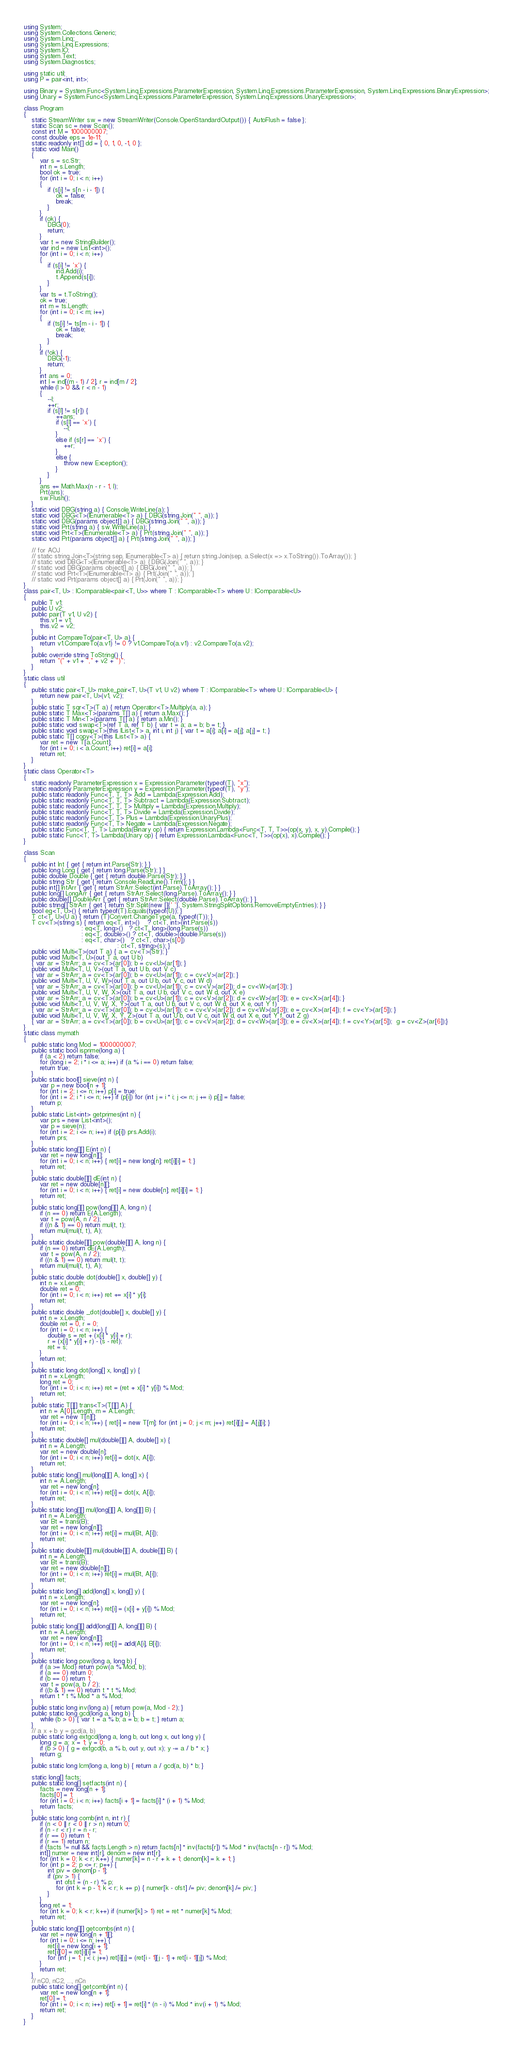<code> <loc_0><loc_0><loc_500><loc_500><_C#_>using System;
using System.Collections.Generic;
using System.Linq;
using System.Linq.Expressions;
using System.IO;
using System.Text;
using System.Diagnostics;

using static util;
using P = pair<int, int>;

using Binary = System.Func<System.Linq.Expressions.ParameterExpression, System.Linq.Expressions.ParameterExpression, System.Linq.Expressions.BinaryExpression>;
using Unary = System.Func<System.Linq.Expressions.ParameterExpression, System.Linq.Expressions.UnaryExpression>;

class Program
{
    static StreamWriter sw = new StreamWriter(Console.OpenStandardOutput()) { AutoFlush = false };
    static Scan sc = new Scan();
    const int M = 1000000007;
    const double eps = 1e-11;
    static readonly int[] dd = { 0, 1, 0, -1, 0 };
    static void Main()
    {
        var s = sc.Str;
        int n = s.Length;
        bool ok = true;
        for (int i = 0; i < n; i++)
        {
            if (s[i] != s[n - i - 1]) {
                ok = false;
                break;
            }
        }
        if (ok) {
            DBG(0);
            return;
        }
        var t = new StringBuilder();
        var ind = new List<int>();
        for (int i = 0; i < n; i++)
        {
            if (s[i] != 'x') {
                ind.Add(i);
                t.Append(s[i]);
            }
        }
        var ts = t.ToString();
        ok = true;
        int m = ts.Length;
        for (int i = 0; i < m; i++)
        {
            if (ts[i] != ts[m - i - 1]) {
                ok = false;
                break;
            }
        }
        if (!ok) {
            DBG(-1);
            return;
        }
        int ans = 0;
        int l = ind[(m - 1) / 2], r = ind[m / 2];
        while (l > 0 && r < n - 1)
        {
            --l;
            ++r;
            if (s[l] != s[r]) {
                ++ans;
                if (s[l] == 'x') {
                    --l;
                }
                else if (s[r] == 'x') {
                    ++r;
                }
                else {
                    throw new Exception();
                }
            }
        }
        ans += Math.Max(n - r - 1, l);
        Prt(ans);
        sw.Flush();
    }
    static void DBG(string a) { Console.WriteLine(a); }
    static void DBG<T>(IEnumerable<T> a) { DBG(string.Join(" ", a)); }
    static void DBG(params object[] a) { DBG(string.Join(" ", a)); }
    static void Prt(string a) { sw.WriteLine(a); }
    static void Prt<T>(IEnumerable<T> a) { Prt(string.Join(" ", a)); }
    static void Prt(params object[] a) { Prt(string.Join(" ", a)); }

    // for AOJ
    // static string Join<T>(string sep, IEnumerable<T> a) { return string.Join(sep, a.Select(x => x.ToString()).ToArray()); }
    // static void DBG<T>(IEnumerable<T> a) { DBG(Join(" ", a)); }
    // static void DBG(params object[] a) { DBG(Join(" ", a)); }
    // static void Prt<T>(IEnumerable<T> a) { Prt(Join(" ", a)); }
    // static void Prt(params object[] a) { Prt(Join(" ", a)); }
}
class pair<T, U> : IComparable<pair<T, U>> where T : IComparable<T> where U : IComparable<U>
{
    public T v1;
    public U v2;
    public pair(T v1, U v2) {
        this.v1 = v1;
        this.v2 = v2;
    }
    public int CompareTo(pair<T, U> a) {
        return v1.CompareTo(a.v1) != 0 ? v1.CompareTo(a.v1) : v2.CompareTo(a.v2);
    }
    public override string ToString() {
        return "(" + v1 + "," + v2 + ")";
    }
}
static class util
{
    public static pair<T, U> make_pair<T, U>(T v1, U v2) where T : IComparable<T> where U : IComparable<U> {
        return new pair<T, U>(v1, v2);
    }
    public static T sqr<T>(T a) { return Operator<T>.Multiply(a, a); }
    public static T Max<T>(params T[] a) { return a.Max(); }
    public static T Min<T>(params T[] a) { return a.Min(); }
    public static void swap<T>(ref T a, ref T b) { var t = a; a = b; b = t; }
    public static void swap<T>(this IList<T> a, int i, int j) { var t = a[i]; a[i] = a[j]; a[j] = t; }
    public static T[] copy<T>(this IList<T> a) {
        var ret = new T[a.Count];
        for (int i = 0; i < a.Count; i++) ret[i] = a[i];
        return ret;
    }
}
static class Operator<T>
{
    static readonly ParameterExpression x = Expression.Parameter(typeof(T), "x");
    static readonly ParameterExpression y = Expression.Parameter(typeof(T), "y");
    public static readonly Func<T, T, T> Add = Lambda(Expression.Add);
    public static readonly Func<T, T, T> Subtract = Lambda(Expression.Subtract);
    public static readonly Func<T, T, T> Multiply = Lambda(Expression.Multiply);
    public static readonly Func<T, T, T> Divide = Lambda(Expression.Divide);
    public static readonly Func<T, T> Plus = Lambda(Expression.UnaryPlus);
    public static readonly Func<T, T> Negate = Lambda(Expression.Negate);
    public static Func<T, T, T> Lambda(Binary op) { return Expression.Lambda<Func<T, T, T>>(op(x, y), x, y).Compile(); }
    public static Func<T, T> Lambda(Unary op) { return Expression.Lambda<Func<T, T>>(op(x), x).Compile(); }
}

class Scan
{
    public int Int { get { return int.Parse(Str); } }
    public long Long { get { return long.Parse(Str); } }
    public double Double { get { return double.Parse(Str); } }
    public string Str { get { return Console.ReadLine().Trim(); } }
    public int[] IntArr { get { return StrArr.Select(int.Parse).ToArray(); } }
    public long[] LongArr { get { return StrArr.Select(long.Parse).ToArray(); } }
    public double[] DoubleArr { get { return StrArr.Select(double.Parse).ToArray(); } }
    public string[] StrArr { get { return Str.Split(new []{' '}, System.StringSplitOptions.RemoveEmptyEntries); } }
    bool eq<T, U>() { return typeof(T).Equals(typeof(U)); }
    T ct<T, U>(U a) { return (T)Convert.ChangeType(a, typeof(T)); }
    T cv<T>(string s) { return eq<T, int>()    ? ct<T, int>(int.Parse(s))
                             : eq<T, long>()   ? ct<T, long>(long.Parse(s))
                             : eq<T, double>() ? ct<T, double>(double.Parse(s))
                             : eq<T, char>()   ? ct<T, char>(s[0])
                                               : ct<T, string>(s); }
    public void Multi<T>(out T a) { a = cv<T>(Str); }
    public void Multi<T, U>(out T a, out U b)
    { var ar = StrArr; a = cv<T>(ar[0]); b = cv<U>(ar[1]); }
    public void Multi<T, U, V>(out T a, out U b, out V c)
    { var ar = StrArr; a = cv<T>(ar[0]); b = cv<U>(ar[1]); c = cv<V>(ar[2]); }
    public void Multi<T, U, V, W>(out T a, out U b, out V c, out W d)
    { var ar = StrArr; a = cv<T>(ar[0]); b = cv<U>(ar[1]); c = cv<V>(ar[2]); d = cv<W>(ar[3]); }
    public void Multi<T, U, V, W, X>(out T a, out U b, out V c, out W d, out X e)
    { var ar = StrArr; a = cv<T>(ar[0]); b = cv<U>(ar[1]); c = cv<V>(ar[2]); d = cv<W>(ar[3]); e = cv<X>(ar[4]); }
    public void Multi<T, U, V, W, X, Y>(out T a, out U b, out V c, out W d, out X e, out Y f)
    { var ar = StrArr; a = cv<T>(ar[0]); b = cv<U>(ar[1]); c = cv<V>(ar[2]); d = cv<W>(ar[3]); e = cv<X>(ar[4]); f = cv<Y>(ar[5]); }
    public void Multi<T, U, V, W, X, Y, Z>(out T a, out U b, out V c, out W d, out X e, out Y f, out Z g)
    { var ar = StrArr; a = cv<T>(ar[0]); b = cv<U>(ar[1]); c = cv<V>(ar[2]); d = cv<W>(ar[3]); e = cv<X>(ar[4]); f = cv<Y>(ar[5]);  g = cv<Z>(ar[6]);}
}
static class mymath
{
    public static long Mod = 1000000007;
    public static bool isprime(long a) {
        if (a < 2) return false;
        for (long i = 2; i * i <= a; i++) if (a % i == 0) return false;
        return true;
    }
    public static bool[] sieve(int n) {
        var p = new bool[n + 1];
        for (int i = 2; i <= n; i++) p[i] = true;
        for (int i = 2; i * i <= n; i++) if (p[i]) for (int j = i * i; j <= n; j += i) p[j] = false;
        return p;
    }
    public static List<int> getprimes(int n) {
        var prs = new List<int>();
        var p = sieve(n);
        for (int i = 2; i <= n; i++) if (p[i]) prs.Add(i);
        return prs;
    }
    public static long[][] E(int n) {
        var ret = new long[n][];
        for (int i = 0; i < n; i++) { ret[i] = new long[n]; ret[i][i] = 1; }
        return ret;
    }
    public static double[][] dE(int n) {
        var ret = new double[n][];
        for (int i = 0; i < n; i++) { ret[i] = new double[n]; ret[i][i] = 1; }
        return ret;
    }
    public static long[][] pow(long[][] A, long n) {
        if (n == 0) return E(A.Length);
        var t = pow(A, n / 2);
        if ((n & 1) == 0) return mul(t, t);
        return mul(mul(t, t), A);
    }
    public static double[][] pow(double[][] A, long n) {
        if (n == 0) return dE(A.Length);
        var t = pow(A, n / 2);
        if ((n & 1) == 0) return mul(t, t);
        return mul(mul(t, t), A);
    }
    public static double dot(double[] x, double[] y) {
        int n = x.Length;
        double ret = 0;
        for (int i = 0; i < n; i++) ret += x[i] * y[i];
        return ret;
    }
    public static double _dot(double[] x, double[] y) {
        int n = x.Length;
        double ret = 0, r = 0;
        for (int i = 0; i < n; i++) {
            double s = ret + (x[i] * y[i] + r);
            r = (x[i] * y[i] + r) - (s - ret);
            ret = s;
        }
        return ret;
    }
    public static long dot(long[] x, long[] y) {
        int n = x.Length;
        long ret = 0;
        for (int i = 0; i < n; i++) ret = (ret + x[i] * y[i]) % Mod;
        return ret;
    }
    public static T[][] trans<T>(T[][] A) {
        int n = A[0].Length, m = A.Length;
        var ret = new T[n][];
        for (int i = 0; i < n; i++) { ret[i] = new T[m]; for (int j = 0; j < m; j++) ret[i][j] = A[j][i]; }
        return ret;
    }
    public static double[] mul(double[][] A, double[] x) {
        int n = A.Length;
        var ret = new double[n];
        for (int i = 0; i < n; i++) ret[i] = dot(x, A[i]);
        return ret;
    }
    public static long[] mul(long[][] A, long[] x) {
        int n = A.Length;
        var ret = new long[n];
        for (int i = 0; i < n; i++) ret[i] = dot(x, A[i]);
        return ret;
    }
    public static long[][] mul(long[][] A, long[][] B) {
        int n = A.Length;
        var Bt = trans(B);
        var ret = new long[n][];
        for (int i = 0; i < n; i++) ret[i] = mul(Bt, A[i]);
        return ret;
    }
    public static double[][] mul(double[][] A, double[][] B) {
        int n = A.Length;
        var Bt = trans(B);
        var ret = new double[n][];
        for (int i = 0; i < n; i++) ret[i] = mul(Bt, A[i]);
        return ret;
    }
    public static long[] add(long[] x, long[] y) {
        int n = x.Length;
        var ret = new long[n];
        for (int i = 0; i < n; i++) ret[i] = (x[i] + y[i]) % Mod;
        return ret;
    }
    public static long[][] add(long[][] A, long[][] B) {
        int n = A.Length;
        var ret = new long[n][];
        for (int i = 0; i < n; i++) ret[i] = add(A[i], B[i]);
        return ret;
    }
    public static long pow(long a, long b) {
        if (a >= Mod) return pow(a % Mod, b);
        if (a == 0) return 0;
        if (b == 0) return 1;
        var t = pow(a, b / 2);
        if ((b & 1) == 0) return t * t % Mod;
        return t * t % Mod * a % Mod;
    }
    public static long inv(long a) { return pow(a, Mod - 2); }
    public static long gcd(long a, long b) {
        while (b > 0) { var t = a % b; a = b; b = t; } return a;
    }
    // a x + b y = gcd(a, b)
    public static long extgcd(long a, long b, out long x, out long y) {
        long g = a; x = 1; y = 0;
        if (b > 0) { g = extgcd(b, a % b, out y, out x); y -= a / b * x; }
        return g;
    }
    public static long lcm(long a, long b) { return a / gcd(a, b) * b; }

    static long[] facts;
    public static long[] setfacts(int n) {
        facts = new long[n + 1];
        facts[0] = 1;
        for (int i = 0; i < n; i++) facts[i + 1] = facts[i] * (i + 1) % Mod;
        return facts;
    }
    public static long comb(int n, int r) {
        if (n < 0 || r < 0 || r > n) return 0;
        if (n - r < r) r = n - r;
        if (r == 0) return 1;
        if (r == 1) return n;
        if (facts != null && facts.Length > n) return facts[n] * inv(facts[r]) % Mod * inv(facts[n - r]) % Mod;
        int[] numer = new int[r], denom = new int[r];
        for (int k = 0; k < r; k++) { numer[k] = n - r + k + 1; denom[k] = k + 1; }
        for (int p = 2; p <= r; p++) {
            int piv = denom[p - 1];
            if (piv > 1) {
                int ofst = (n - r) % p;
                for (int k = p - 1; k < r; k += p) { numer[k - ofst] /= piv; denom[k] /= piv; }
            }
        }
        long ret = 1;
        for (int k = 0; k < r; k++) if (numer[k] > 1) ret = ret * numer[k] % Mod;
        return ret;
    }
    public static long[][] getcombs(int n) {
        var ret = new long[n + 1][];
        for (int i = 0; i <= n; i++) {
            ret[i] = new long[i + 1];
            ret[i][0] = ret[i][i] = 1;
            for (int j = 1; j < i; j++) ret[i][j] = (ret[i - 1][j - 1] + ret[i - 1][j]) % Mod;
        }
        return ret;
    }
    // nC0, nC2, ..., nCn
    public static long[] getcomb(int n) {
        var ret = new long[n + 1];
        ret[0] = 1;
        for (int i = 0; i < n; i++) ret[i + 1] = ret[i] * (n - i) % Mod * inv(i + 1) % Mod;
        return ret;
    }
}
</code> 